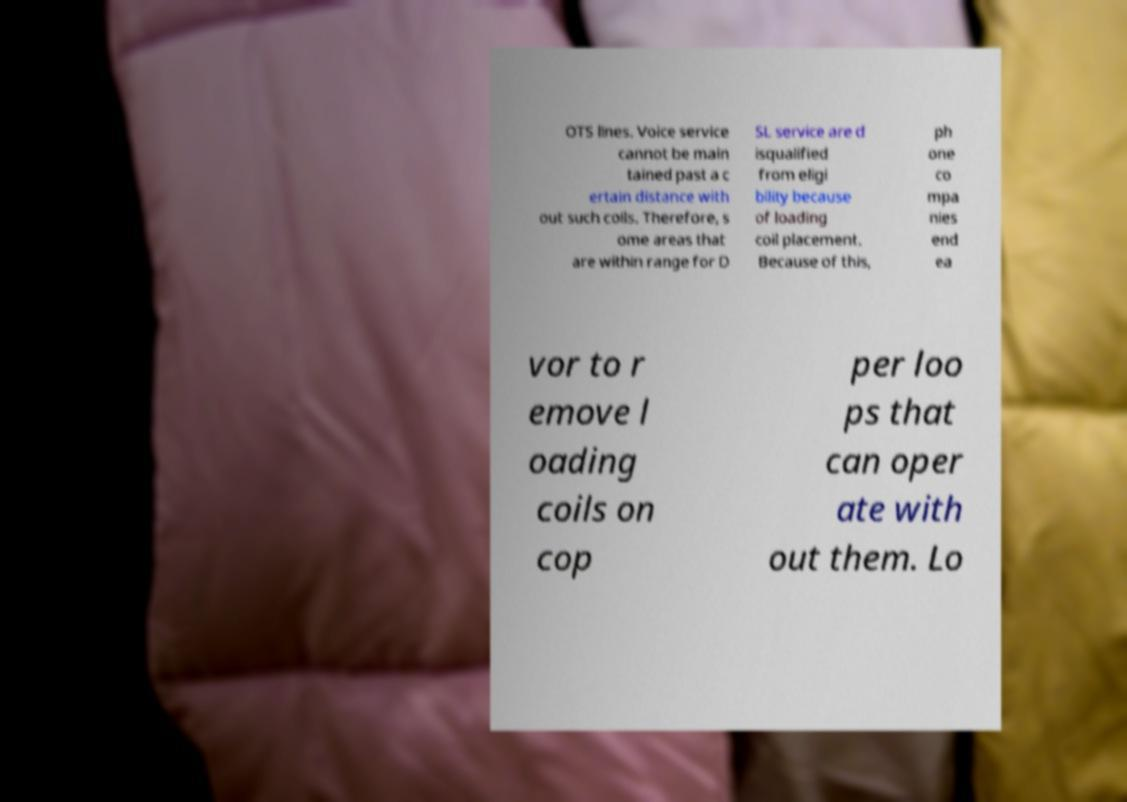What messages or text are displayed in this image? I need them in a readable, typed format. OTS lines. Voice service cannot be main tained past a c ertain distance with out such coils. Therefore, s ome areas that are within range for D SL service are d isqualified from eligi bility because of loading coil placement. Because of this, ph one co mpa nies end ea vor to r emove l oading coils on cop per loo ps that can oper ate with out them. Lo 